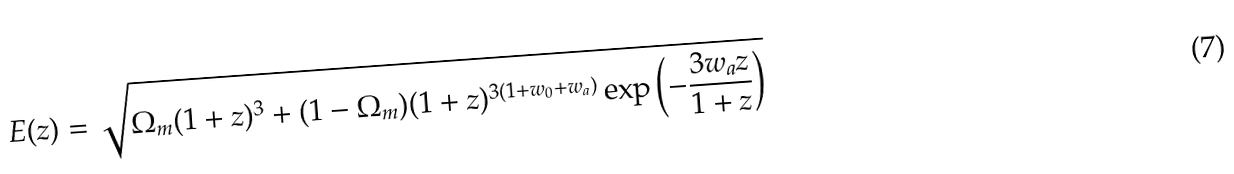Convert formula to latex. <formula><loc_0><loc_0><loc_500><loc_500>E ( z ) = \sqrt { \Omega _ { m } ( 1 + z ) ^ { 3 } + ( 1 - \Omega _ { m } ) ( 1 + z ) ^ { 3 ( 1 + w _ { 0 } + w _ { a } ) } \exp \left ( - \frac { 3 w _ { a } z } { 1 + z } \right ) }</formula> 